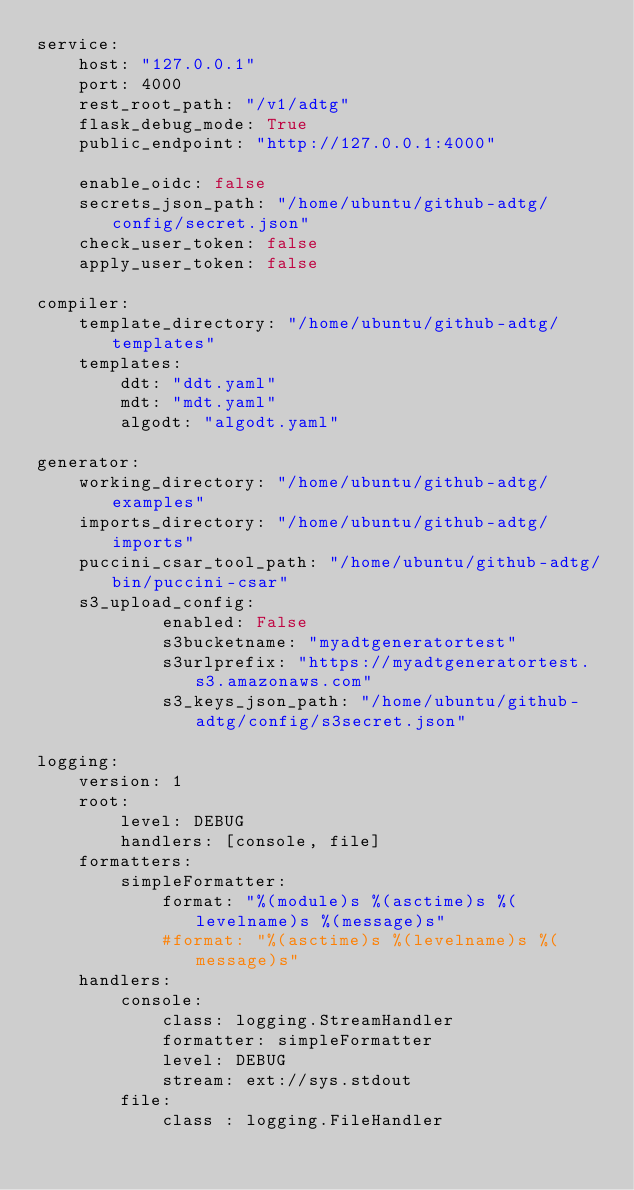Convert code to text. <code><loc_0><loc_0><loc_500><loc_500><_YAML_>service:
    host: "127.0.0.1"
    port: 4000
    rest_root_path: "/v1/adtg"
    flask_debug_mode: True
    public_endpoint: "http://127.0.0.1:4000"

    enable_oidc: false
    secrets_json_path: "/home/ubuntu/github-adtg/config/secret.json"
    check_user_token: false
    apply_user_token: false
    
compiler:
    template_directory: "/home/ubuntu/github-adtg/templates"
    templates:
        ddt: "ddt.yaml"
        mdt: "mdt.yaml"
        algodt: "algodt.yaml"

generator:
    working_directory: "/home/ubuntu/github-adtg/examples"
    imports_directory: "/home/ubuntu/github-adtg/imports"
    puccini_csar_tool_path: "/home/ubuntu/github-adtg/bin/puccini-csar"
    s3_upload_config:
            enabled: False
            s3bucketname: "myadtgeneratortest"
            s3urlprefix: "https://myadtgeneratortest.s3.amazonaws.com"
            s3_keys_json_path: "/home/ubuntu/github-adtg/config/s3secret.json"

logging:
    version: 1
    root:
        level: DEBUG
        handlers: [console, file]
    formatters:
        simpleFormatter:
            format: "%(module)s %(asctime)s %(levelname)s %(message)s"
            #format: "%(asctime)s %(levelname)s %(message)s"
    handlers:
        console:
            class: logging.StreamHandler
            formatter: simpleFormatter
            level: DEBUG
            stream: ext://sys.stdout
        file:
            class : logging.FileHandler</code> 